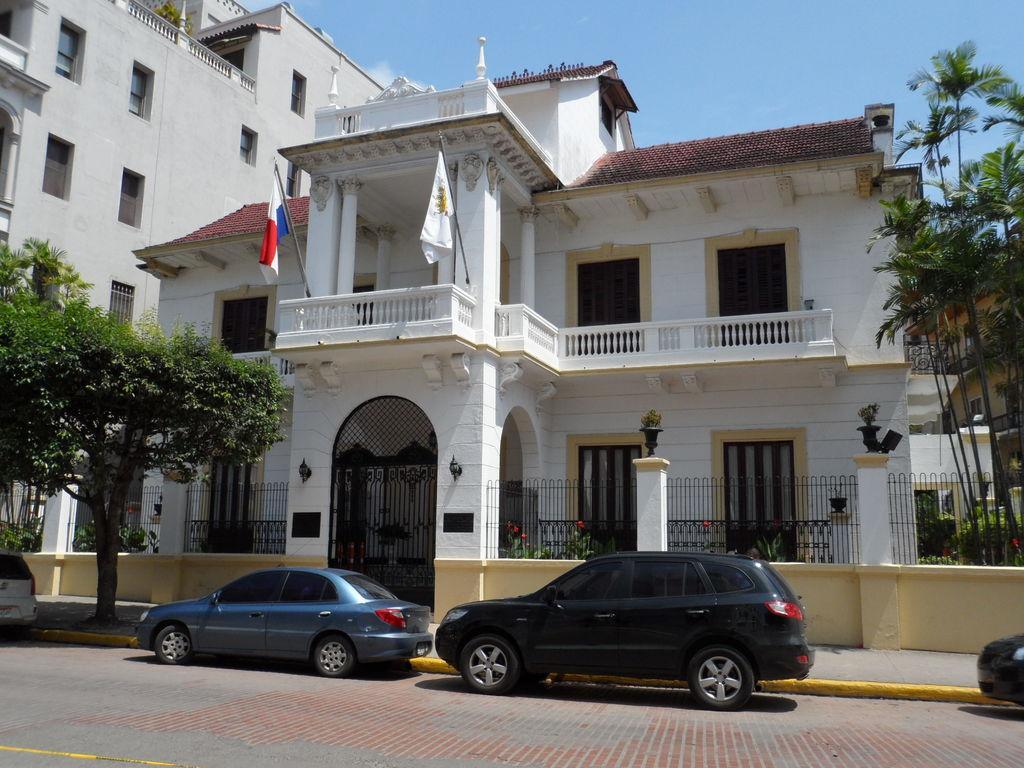Please provide a concise description of this image. In this picture we can see few cars on the road, beside to the cars we can find few trees, fence and few buildings, and also we can find few flags. 